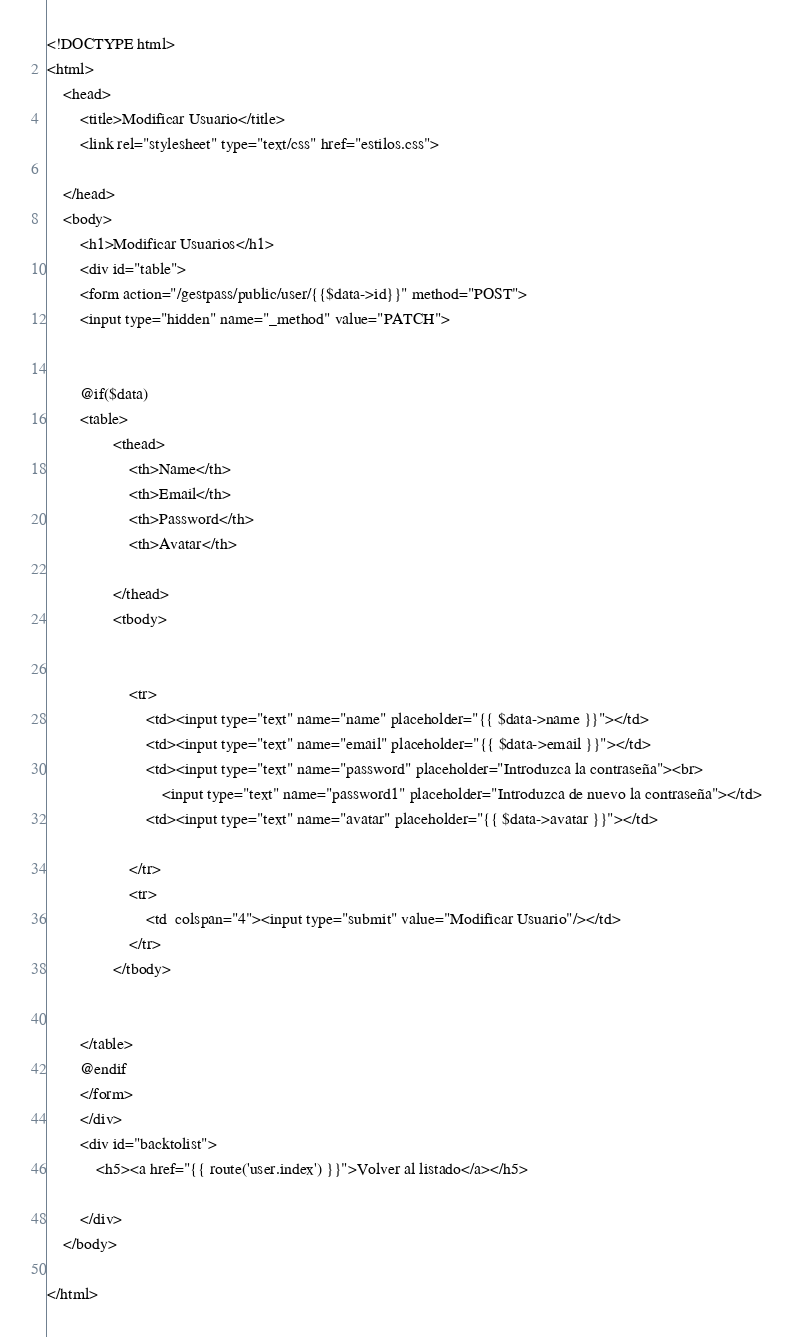<code> <loc_0><loc_0><loc_500><loc_500><_PHP_><!DOCTYPE html>
<html>
    <head>
        <title>Modificar Usuario</title>
        <link rel="stylesheet" type="text/css" href="estilos.css">
        
    </head>    
    <body>
        <h1>Modificar Usuarios</h1>
        <div id="table">
        <form action="/gestpass/public/user/{{$data->id}}" method="POST">
        <input type="hidden" name="_method" value="PATCH">
        
       
        @if($data)
        <table>
                <thead>
                    <th>Name</th>
                    <th>Email</th>
                    <th>Password</th>
                    <th>Avatar</th>
   
                </thead>
                <tbody>
                
                
                    <tr>
                        <td><input type="text" name="name" placeholder="{{ $data->name }}"></td>
                        <td><input type="text" name="email" placeholder="{{ $data->email }}"></td>
                        <td><input type="text" name="password" placeholder="Introduzca la contraseña"><br>
                            <input type="text" name="password1" placeholder="Introduzca de nuevo la contraseña"></td>
                        <td><input type="text" name="avatar" placeholder="{{ $data->avatar }}"></td>
                       
                    </tr>
                    <tr>
                        <td  colspan="4"><input type="submit" value="Modificar Usuario"/></td>
                    </tr>
                </tbody>
                
           
        </table>
        @endif
        </form>
        </div>
        <div id="backtolist">
            <h5><a href="{{ route('user.index') }}">Volver al listado</a></h5>

        </div>
    </body> 
    
</html>

</code> 